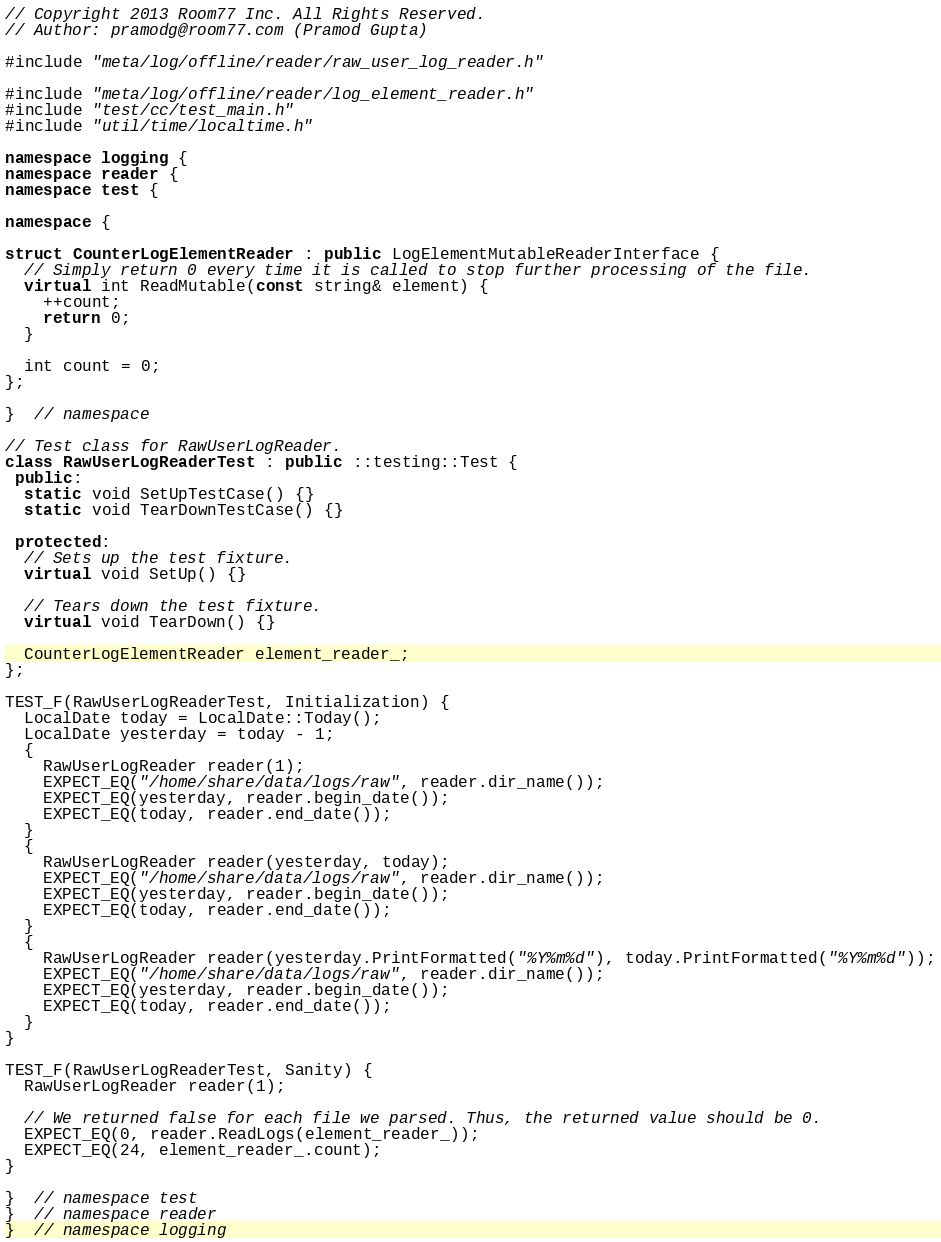Convert code to text. <code><loc_0><loc_0><loc_500><loc_500><_C++_>// Copyright 2013 Room77 Inc. All Rights Reserved.
// Author: pramodg@room77.com (Pramod Gupta)

#include "meta/log/offline/reader/raw_user_log_reader.h"

#include "meta/log/offline/reader/log_element_reader.h"
#include "test/cc/test_main.h"
#include "util/time/localtime.h"

namespace logging {
namespace reader {
namespace test {

namespace {

struct CounterLogElementReader : public LogElementMutableReaderInterface {
  // Simply return 0 every time it is called to stop further processing of the file.
  virtual int ReadMutable(const string& element) {
    ++count;
    return 0;
  }

  int count = 0;
};

}  // namespace

// Test class for RawUserLogReader.
class RawUserLogReaderTest : public ::testing::Test {
 public:
  static void SetUpTestCase() {}
  static void TearDownTestCase() {}

 protected:
  // Sets up the test fixture.
  virtual void SetUp() {}

  // Tears down the test fixture.
  virtual void TearDown() {}

  CounterLogElementReader element_reader_;
};

TEST_F(RawUserLogReaderTest, Initialization) {
  LocalDate today = LocalDate::Today();
  LocalDate yesterday = today - 1;
  {
    RawUserLogReader reader(1);
    EXPECT_EQ("/home/share/data/logs/raw", reader.dir_name());
    EXPECT_EQ(yesterday, reader.begin_date());
    EXPECT_EQ(today, reader.end_date());
  }
  {
    RawUserLogReader reader(yesterday, today);
    EXPECT_EQ("/home/share/data/logs/raw", reader.dir_name());
    EXPECT_EQ(yesterday, reader.begin_date());
    EXPECT_EQ(today, reader.end_date());
  }
  {
    RawUserLogReader reader(yesterday.PrintFormatted("%Y%m%d"), today.PrintFormatted("%Y%m%d"));
    EXPECT_EQ("/home/share/data/logs/raw", reader.dir_name());
    EXPECT_EQ(yesterday, reader.begin_date());
    EXPECT_EQ(today, reader.end_date());
  }
}

TEST_F(RawUserLogReaderTest, Sanity) {
  RawUserLogReader reader(1);

  // We returned false for each file we parsed. Thus, the returned value should be 0.
  EXPECT_EQ(0, reader.ReadLogs(element_reader_));
  EXPECT_EQ(24, element_reader_.count);
}

}  // namespace test
}  // namespace reader
}  // namespace logging
</code> 